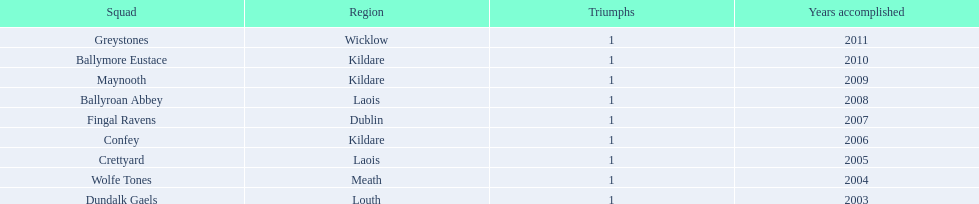How many wins did confey have? 1. 